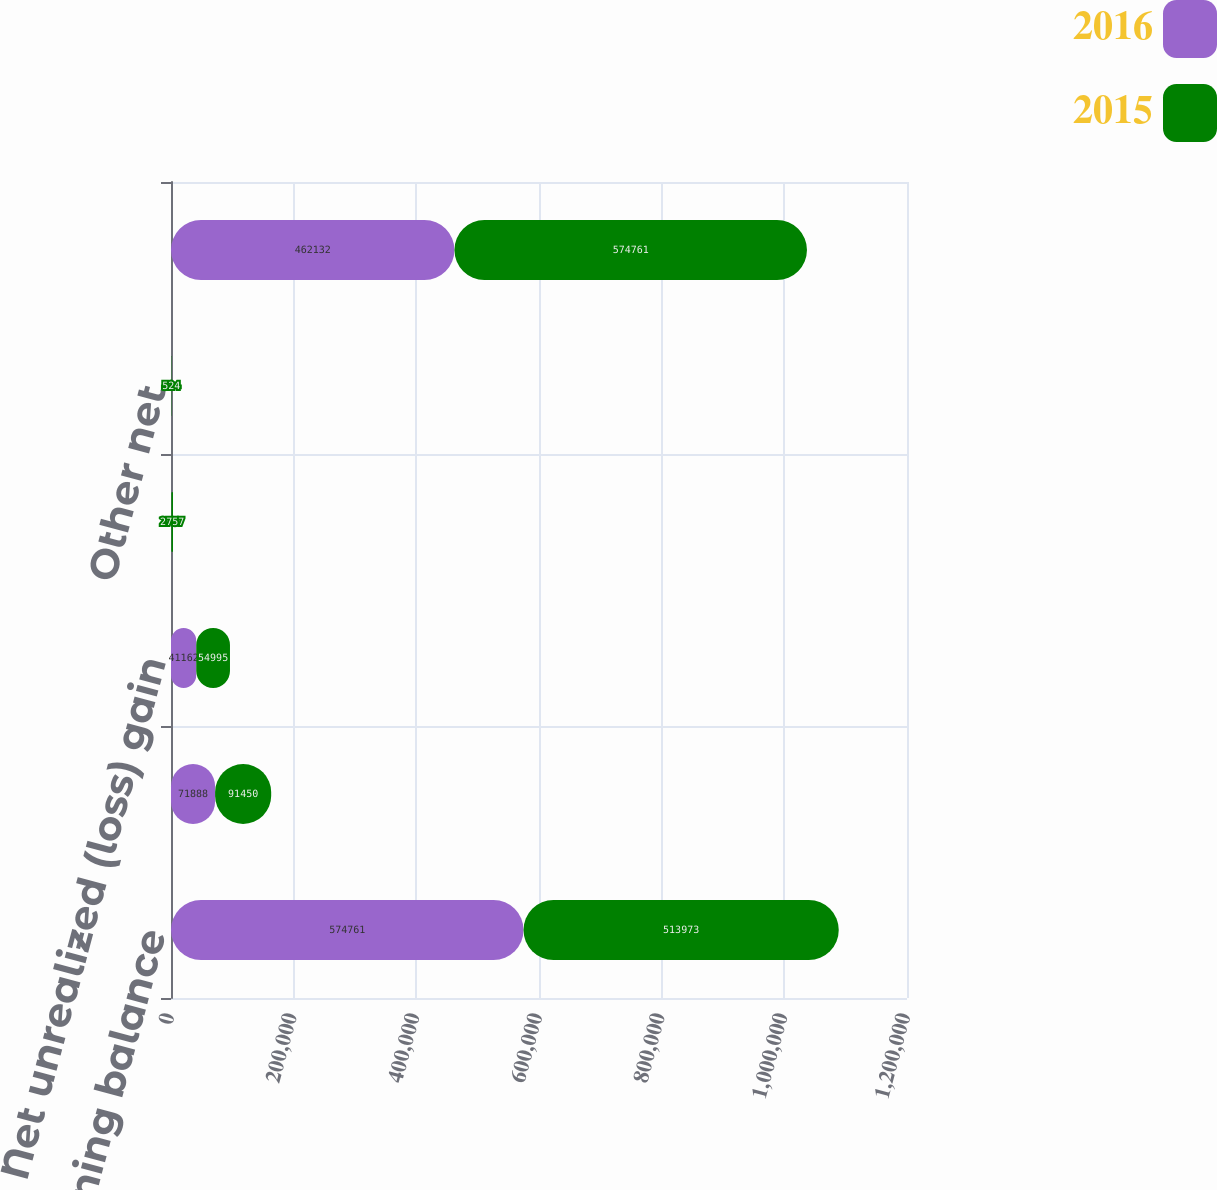Convert chart to OTSL. <chart><loc_0><loc_0><loc_500><loc_500><stacked_bar_chart><ecel><fcel>Beginning balance<fcel>Dispositions/distributions<fcel>Net unrealized (loss) gain<fcel>Net realized gain<fcel>Other net<fcel>Ending balance<nl><fcel>2016<fcel>574761<fcel>71888<fcel>41162<fcel>507<fcel>86<fcel>462132<nl><fcel>2015<fcel>513973<fcel>91450<fcel>54995<fcel>2757<fcel>524<fcel>574761<nl></chart> 